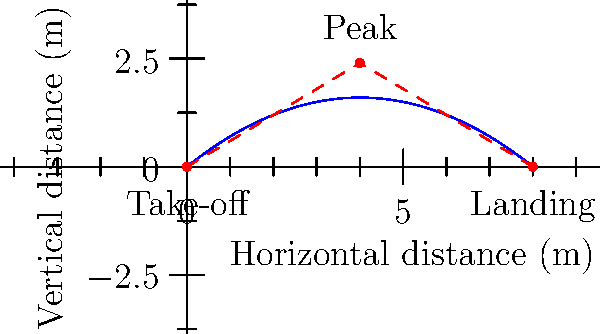During a long jump, the athlete's center of mass follows a parabolic trajectory as shown in the figure. If the horizontal displacement of the center of mass from take-off to landing is 8 meters, and the peak height is reached at the midpoint of the jump, what is the total displacement of the center of mass? To find the total displacement of the center of mass, we need to follow these steps:

1) Identify the start and end points of the center of mass:
   - Start: (0, 0) at take-off
   - End: (8, 0) at landing

2) Calculate the straight-line distance between these points:
   
   $$d = \sqrt{(x_2 - x_1)^2 + (y_2 - y_1)^2}$$
   $$d = \sqrt{(8 - 0)^2 + (0 - 0)^2}$$
   $$d = \sqrt{64 + 0} = 8\text{ meters}$$

3) The total displacement is the straight-line distance between the start and end points, regardless of the path taken.

4) Note that while the center of mass follows a parabolic path, the displacement is measured as the straight-line distance between the initial and final positions.

5) The peak height and the parabolic nature of the trajectory do not affect the displacement calculation, as displacement only considers the start and end points.
Answer: 8 meters 